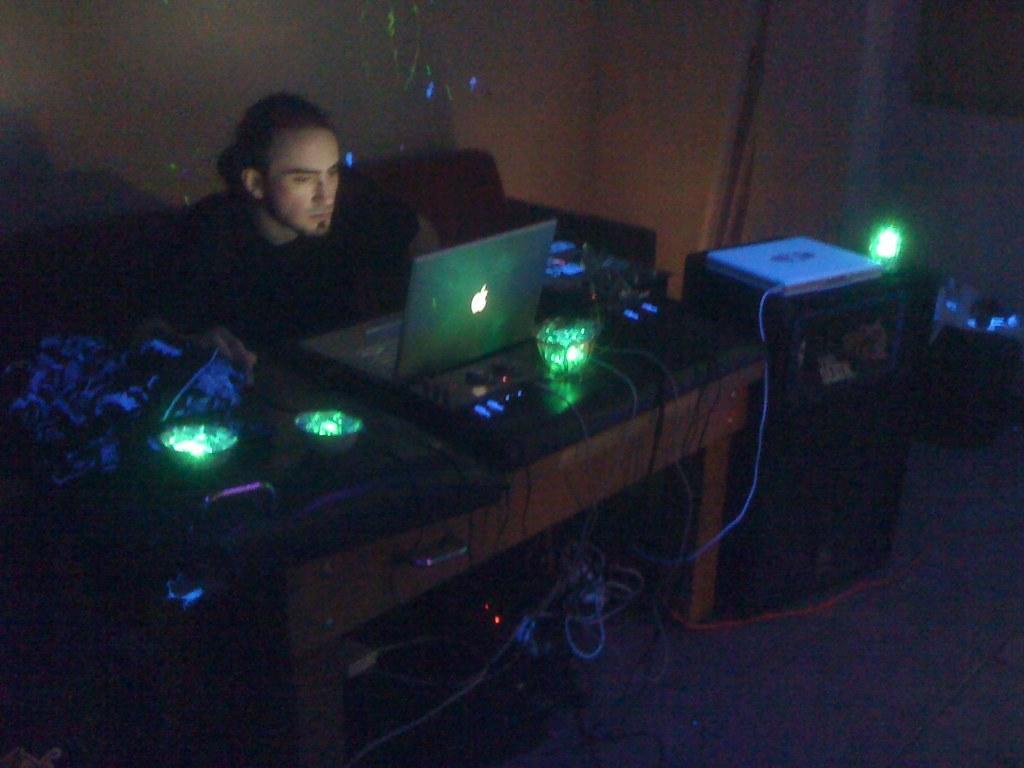In one or two sentences, can you explain what this image depicts? In this picture we can see a man sitting on a sofa, laptops and lights on a table, wires on the floor and in the background we can see the wall. 